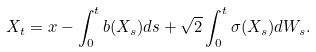Convert formula to latex. <formula><loc_0><loc_0><loc_500><loc_500>X _ { t } = x - \int _ { 0 } ^ { t } b ( X _ { s } ) d s + \sqrt { 2 } \int _ { 0 } ^ { t } \sigma ( X _ { s } ) d W _ { s } .</formula> 